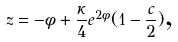<formula> <loc_0><loc_0><loc_500><loc_500>z = - \phi + \frac { \kappa } { 4 } e ^ { 2 \phi } ( 1 - \frac { c } { 2 } ) \text {,}</formula> 